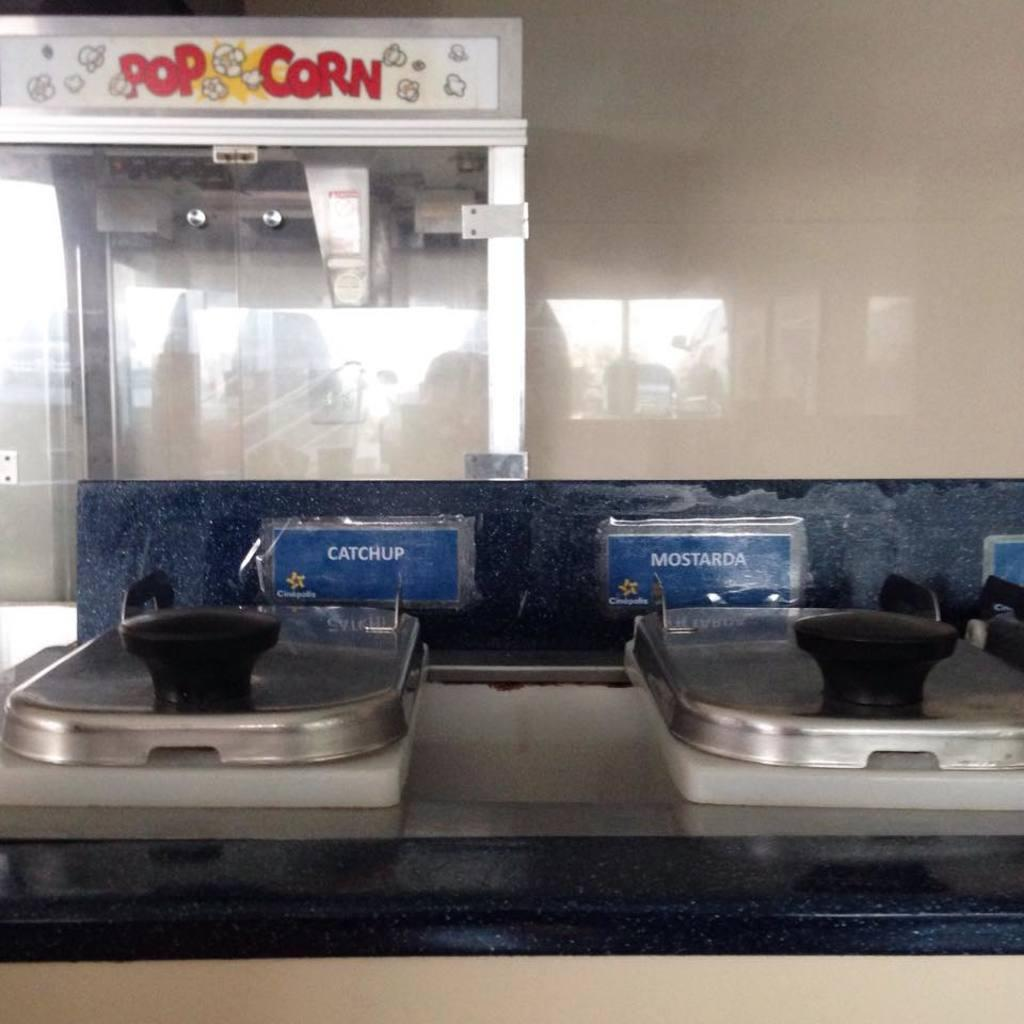Provide a one-sentence caption for the provided image. A condiment station that includes catchup and mostarda with a pop corn machine in the background. 